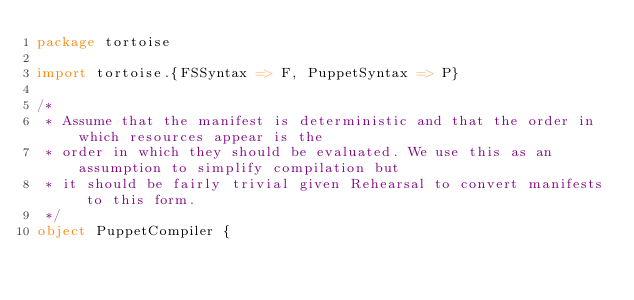<code> <loc_0><loc_0><loc_500><loc_500><_Scala_>package tortoise

import tortoise.{FSSyntax => F, PuppetSyntax => P}

/*
 * Assume that the manifest is deterministic and that the order in which resources appear is the
 * order in which they should be evaluated. We use this as an assumption to simplify compilation but
 * it should be fairly trivial given Rehearsal to convert manifests to this form.
 */
object PuppetCompiler {</code> 